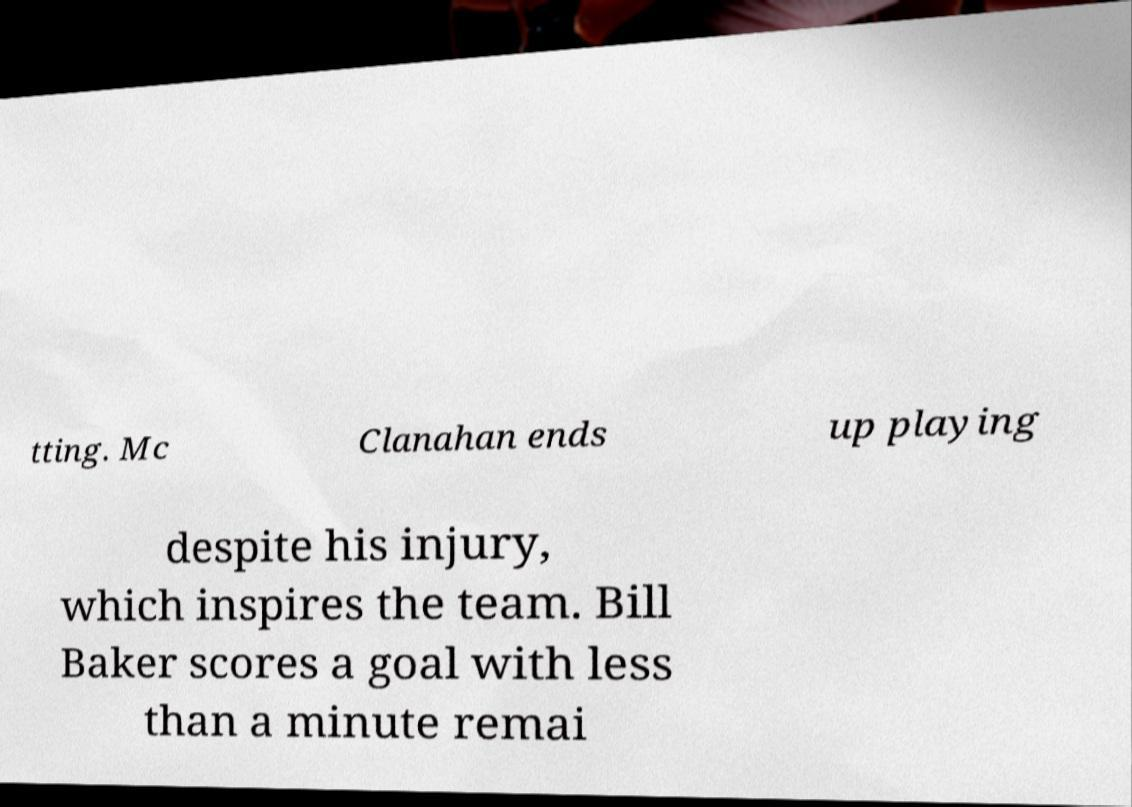Can you accurately transcribe the text from the provided image for me? tting. Mc Clanahan ends up playing despite his injury, which inspires the team. Bill Baker scores a goal with less than a minute remai 